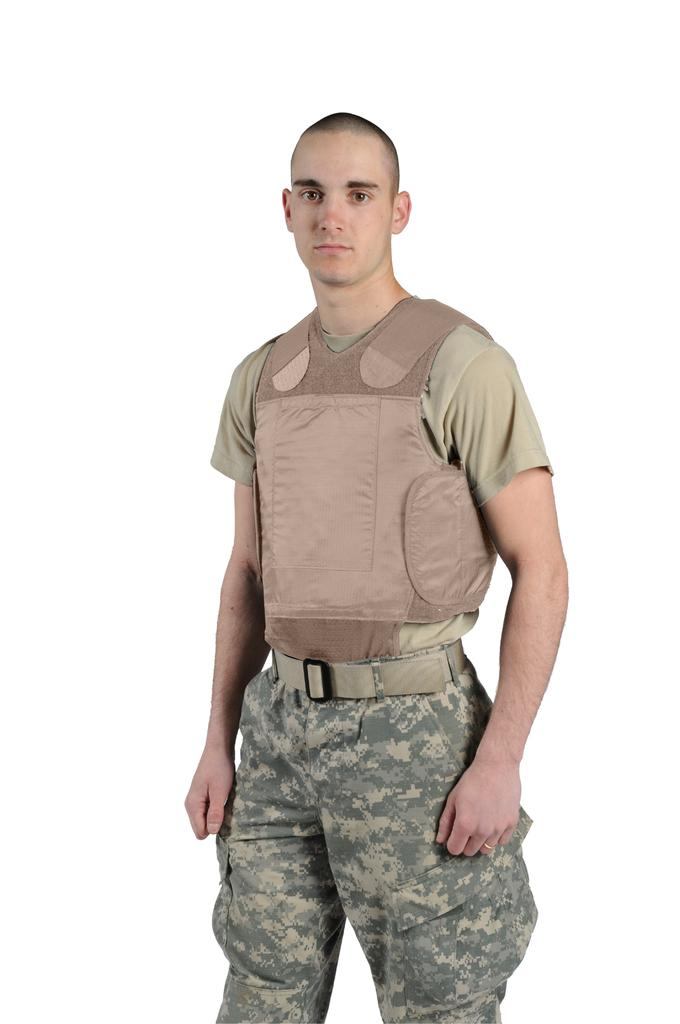What color is the background of the image? The background of the image is white. What can be seen in the middle of the image? There is a man in the middle of the image. What country is the man smiling in pain in the image? There is no information about the man's emotions or location in the image, nor is there any indication of pain. 